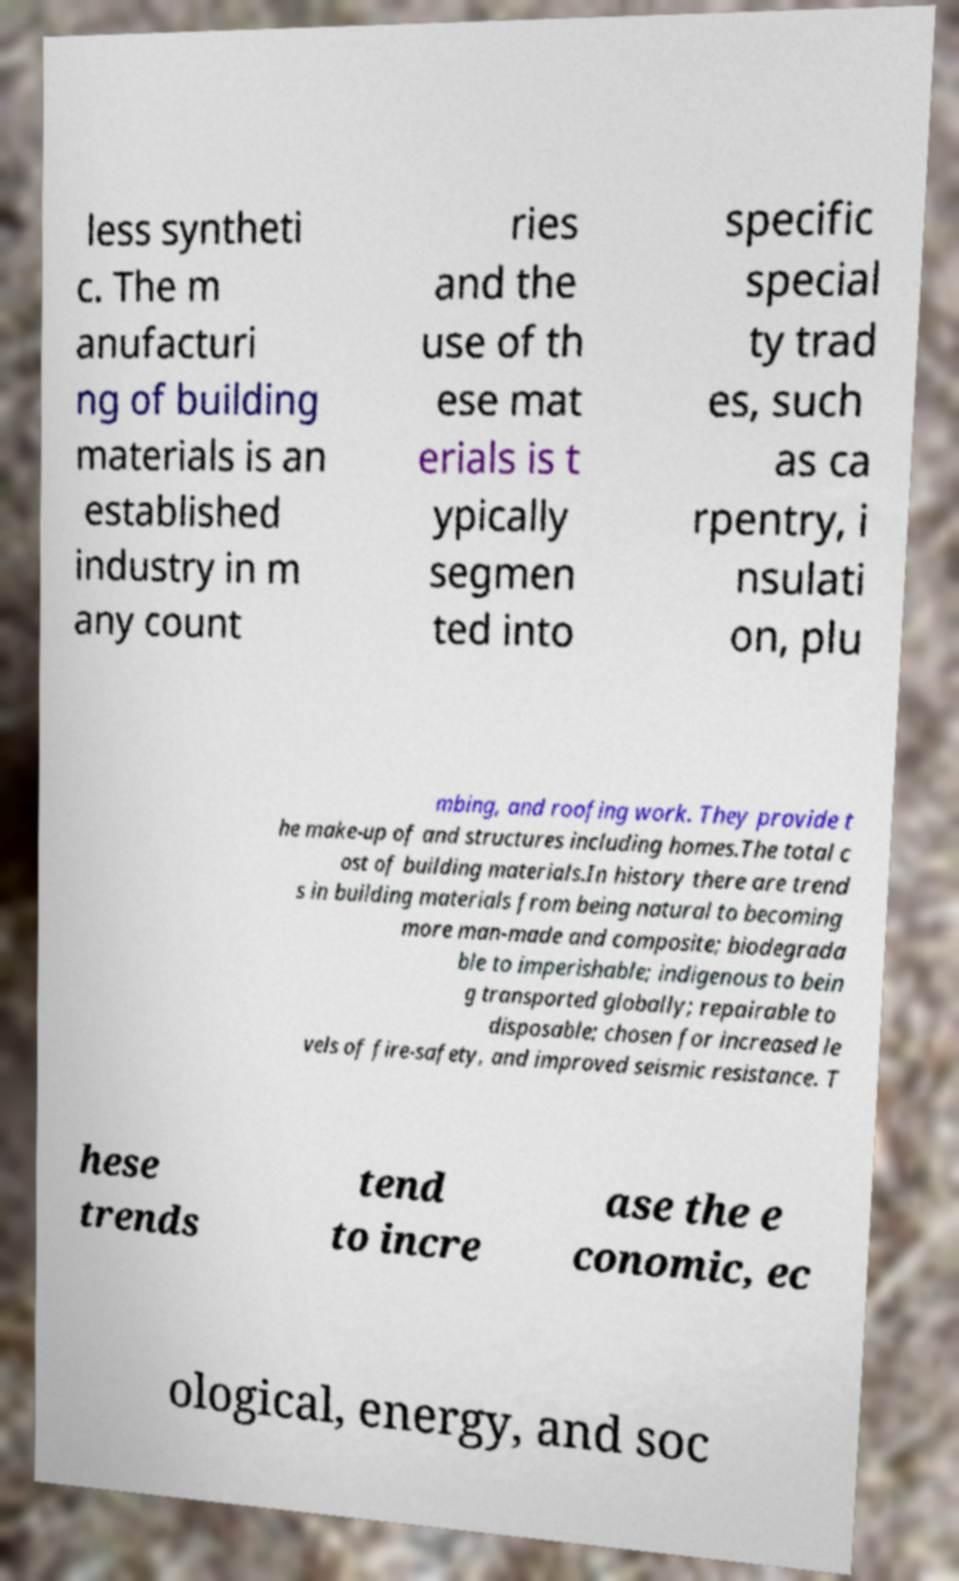Can you accurately transcribe the text from the provided image for me? less syntheti c. The m anufacturi ng of building materials is an established industry in m any count ries and the use of th ese mat erials is t ypically segmen ted into specific special ty trad es, such as ca rpentry, i nsulati on, plu mbing, and roofing work. They provide t he make-up of and structures including homes.The total c ost of building materials.In history there are trend s in building materials from being natural to becoming more man-made and composite; biodegrada ble to imperishable; indigenous to bein g transported globally; repairable to disposable; chosen for increased le vels of fire-safety, and improved seismic resistance. T hese trends tend to incre ase the e conomic, ec ological, energy, and soc 